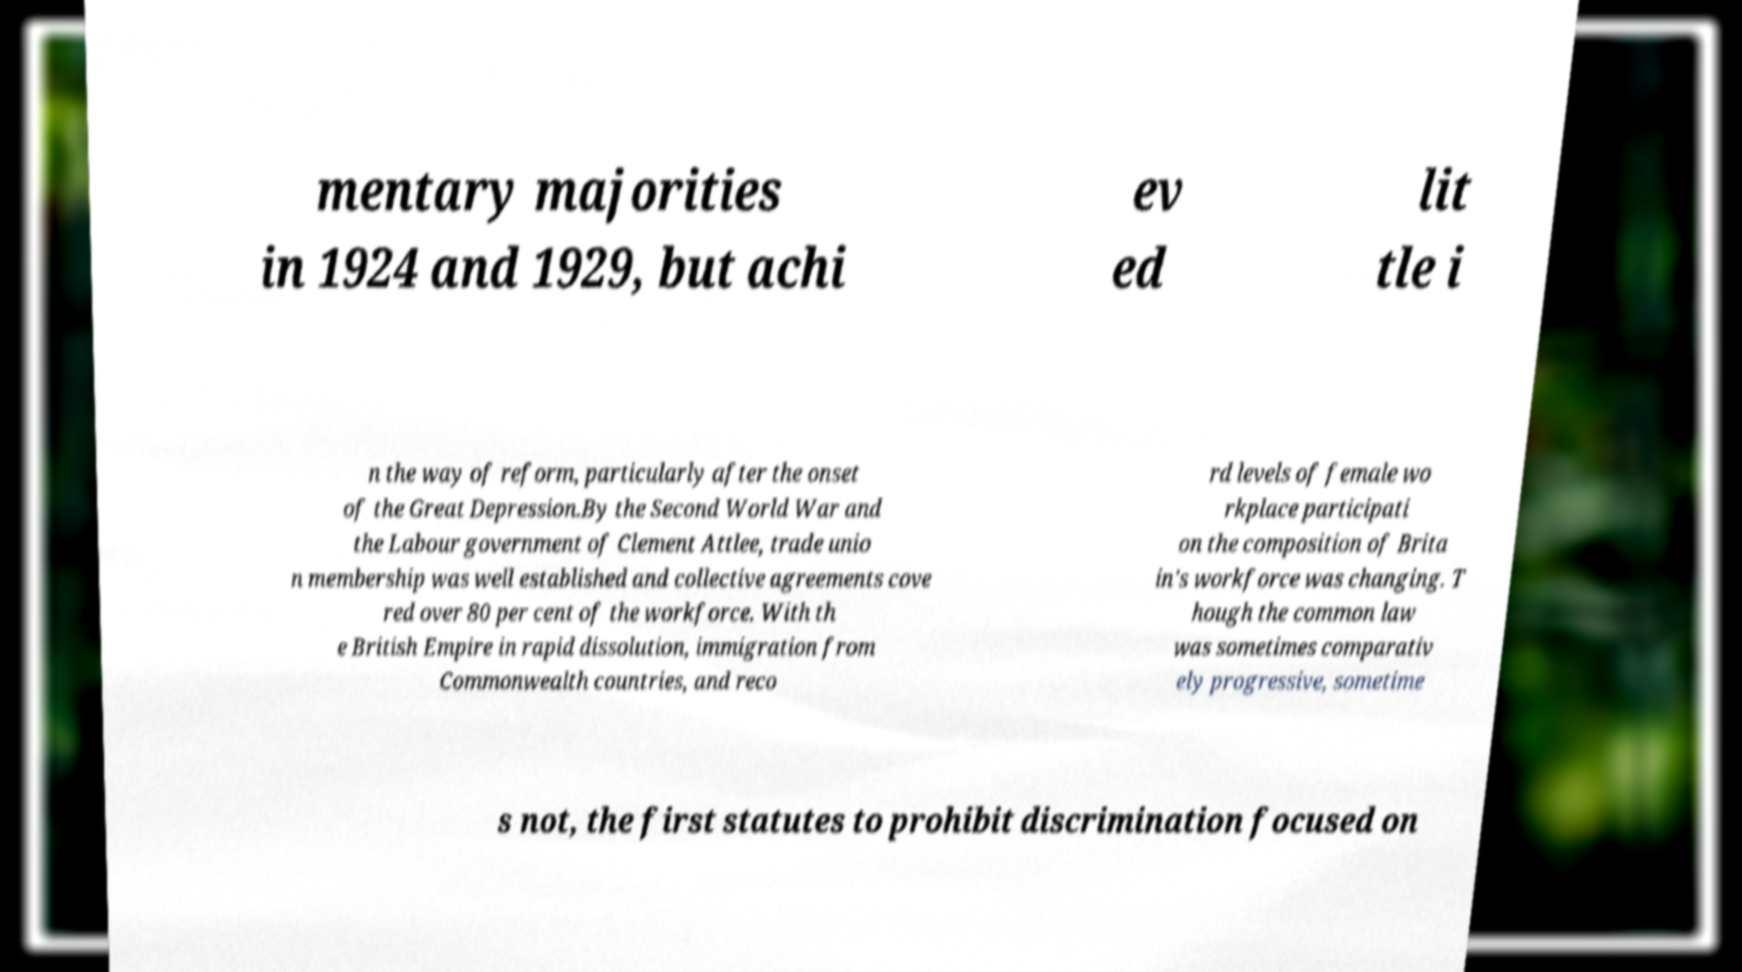Can you read and provide the text displayed in the image?This photo seems to have some interesting text. Can you extract and type it out for me? mentary majorities in 1924 and 1929, but achi ev ed lit tle i n the way of reform, particularly after the onset of the Great Depression.By the Second World War and the Labour government of Clement Attlee, trade unio n membership was well established and collective agreements cove red over 80 per cent of the workforce. With th e British Empire in rapid dissolution, immigration from Commonwealth countries, and reco rd levels of female wo rkplace participati on the composition of Brita in's workforce was changing. T hough the common law was sometimes comparativ ely progressive, sometime s not, the first statutes to prohibit discrimination focused on 